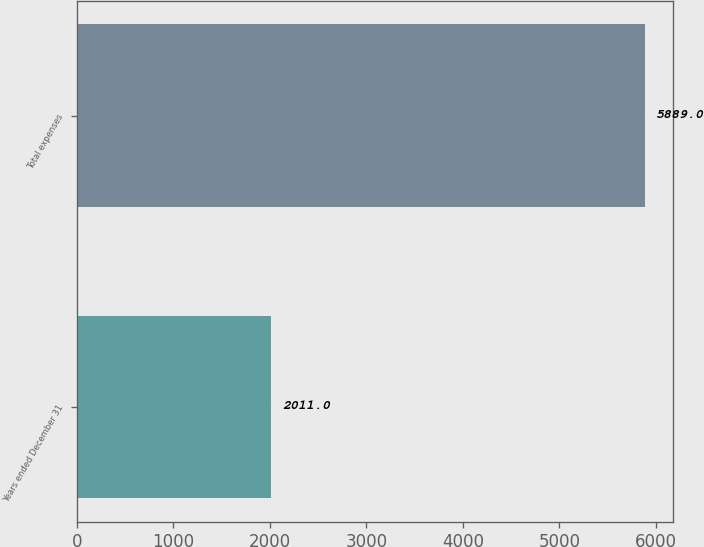Convert chart to OTSL. <chart><loc_0><loc_0><loc_500><loc_500><bar_chart><fcel>Years ended December 31<fcel>Total expenses<nl><fcel>2011<fcel>5889<nl></chart> 